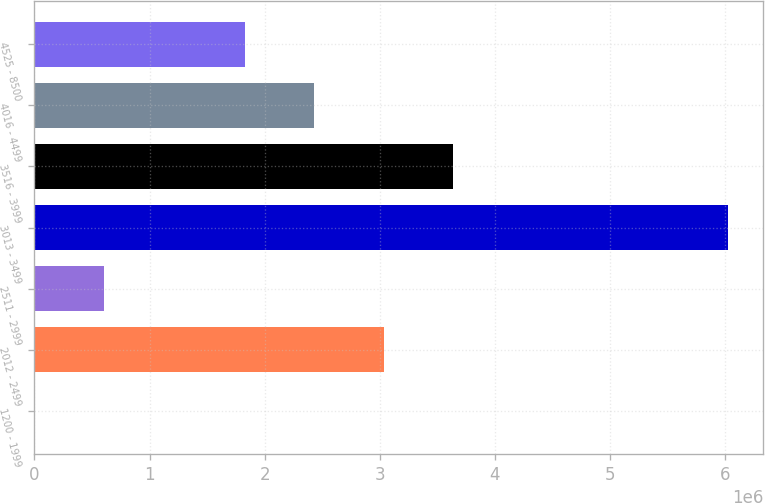Convert chart to OTSL. <chart><loc_0><loc_0><loc_500><loc_500><bar_chart><fcel>1200 - 1999<fcel>2012 - 2499<fcel>2511 - 2999<fcel>3013 - 3499<fcel>3516 - 3999<fcel>4016 - 4499<fcel>4525 - 8500<nl><fcel>5969<fcel>3.03325e+06<fcel>608287<fcel>6.02915e+06<fcel>3.63557e+06<fcel>2.43093e+06<fcel>1.82861e+06<nl></chart> 